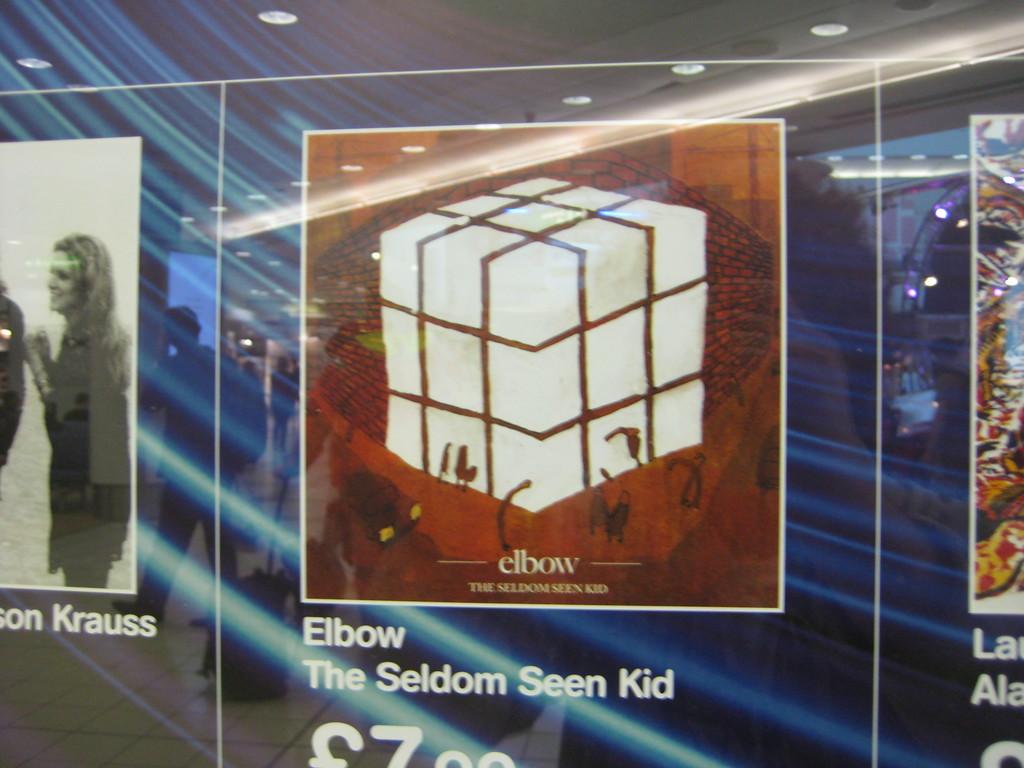What is the title of this album?
Your response must be concise. The seldom seen kid. Who is the artist of this album?
Offer a very short reply. The seldom seen kid. 